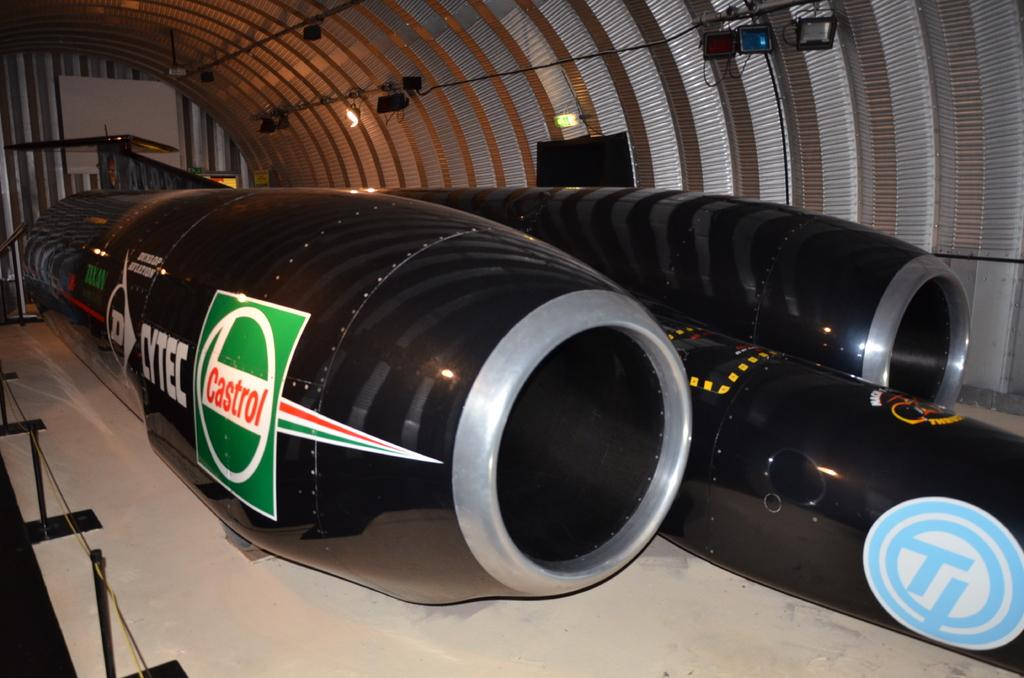<image>
Present a compact description of the photo's key features. A unique vehicle that is painted black with a green and white logo that says Castrol in red 